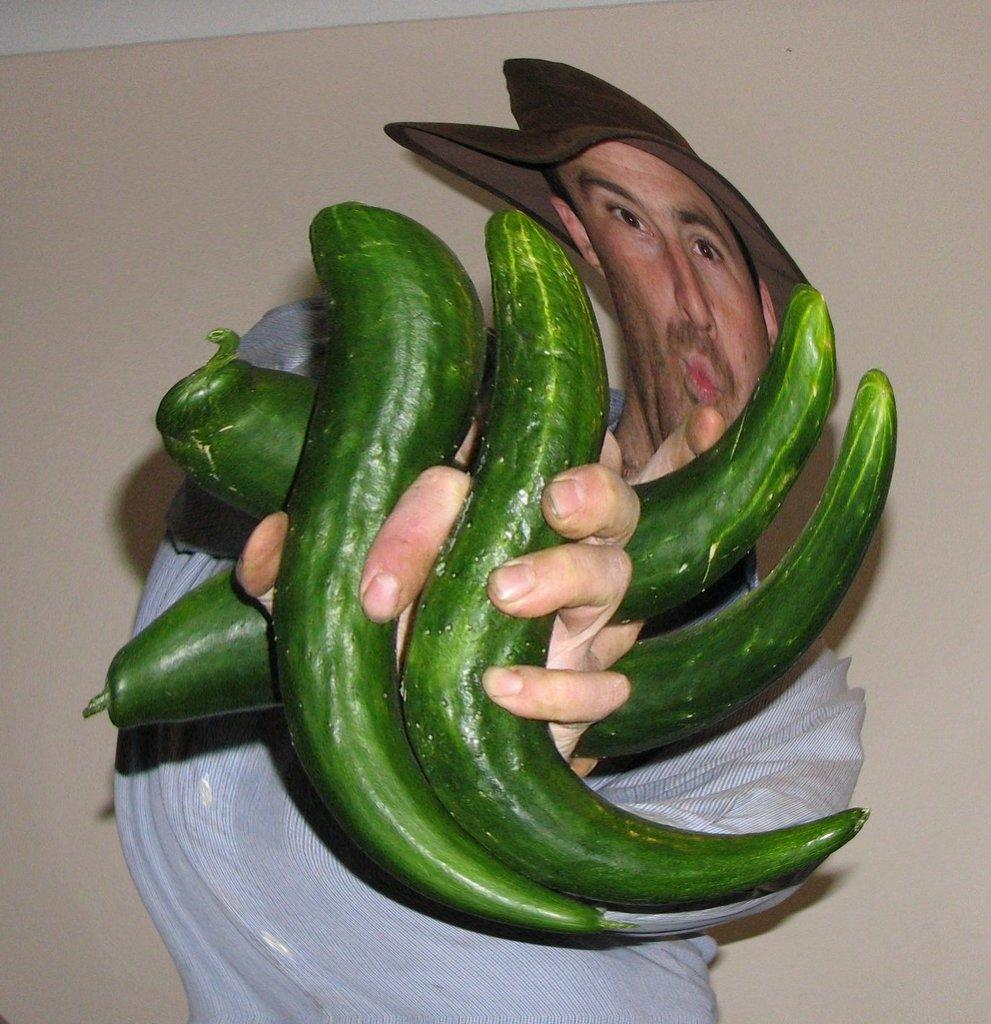What is the main subject of the image? There is a person in the image. What is the person holding in the image? The person is holding green color vegetables. What is the person wearing in the image? The person is wearing a white dress. What color is the background of the image? The background of the image is in cream color. Can you see a monkey playing with a skate in the quicksand in the image? There is no monkey, skate, or quicksand present in the image. 